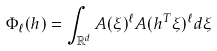<formula> <loc_0><loc_0><loc_500><loc_500>\Phi _ { \ell } ( h ) = \int _ { \mathbb { R } ^ { d } } A ( \xi ) ^ { \ell } A ( h ^ { T } \xi ) ^ { \ell } d \xi</formula> 